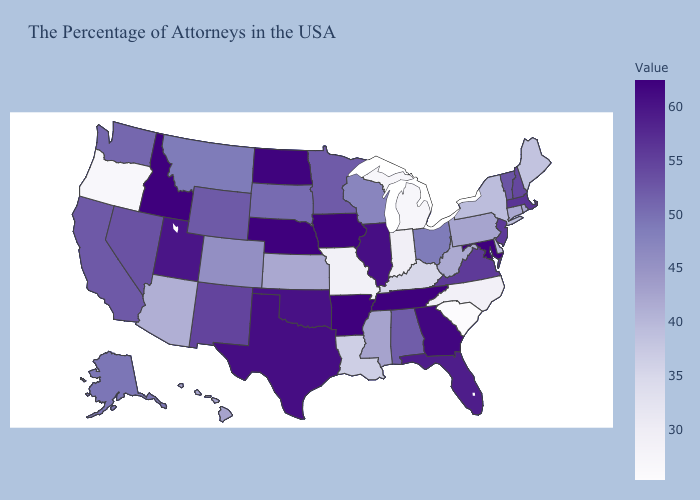Which states hav the highest value in the Northeast?
Short answer required. Massachusetts. Among the states that border Mississippi , which have the highest value?
Be succinct. Tennessee, Arkansas. Which states have the lowest value in the USA?
Short answer required. South Carolina. Does the map have missing data?
Be succinct. No. Is the legend a continuous bar?
Keep it brief. Yes. Among the states that border Kentucky , does Illinois have the highest value?
Give a very brief answer. No. Which states have the lowest value in the USA?
Write a very short answer. South Carolina. Does Utah have a higher value than Pennsylvania?
Give a very brief answer. Yes. 